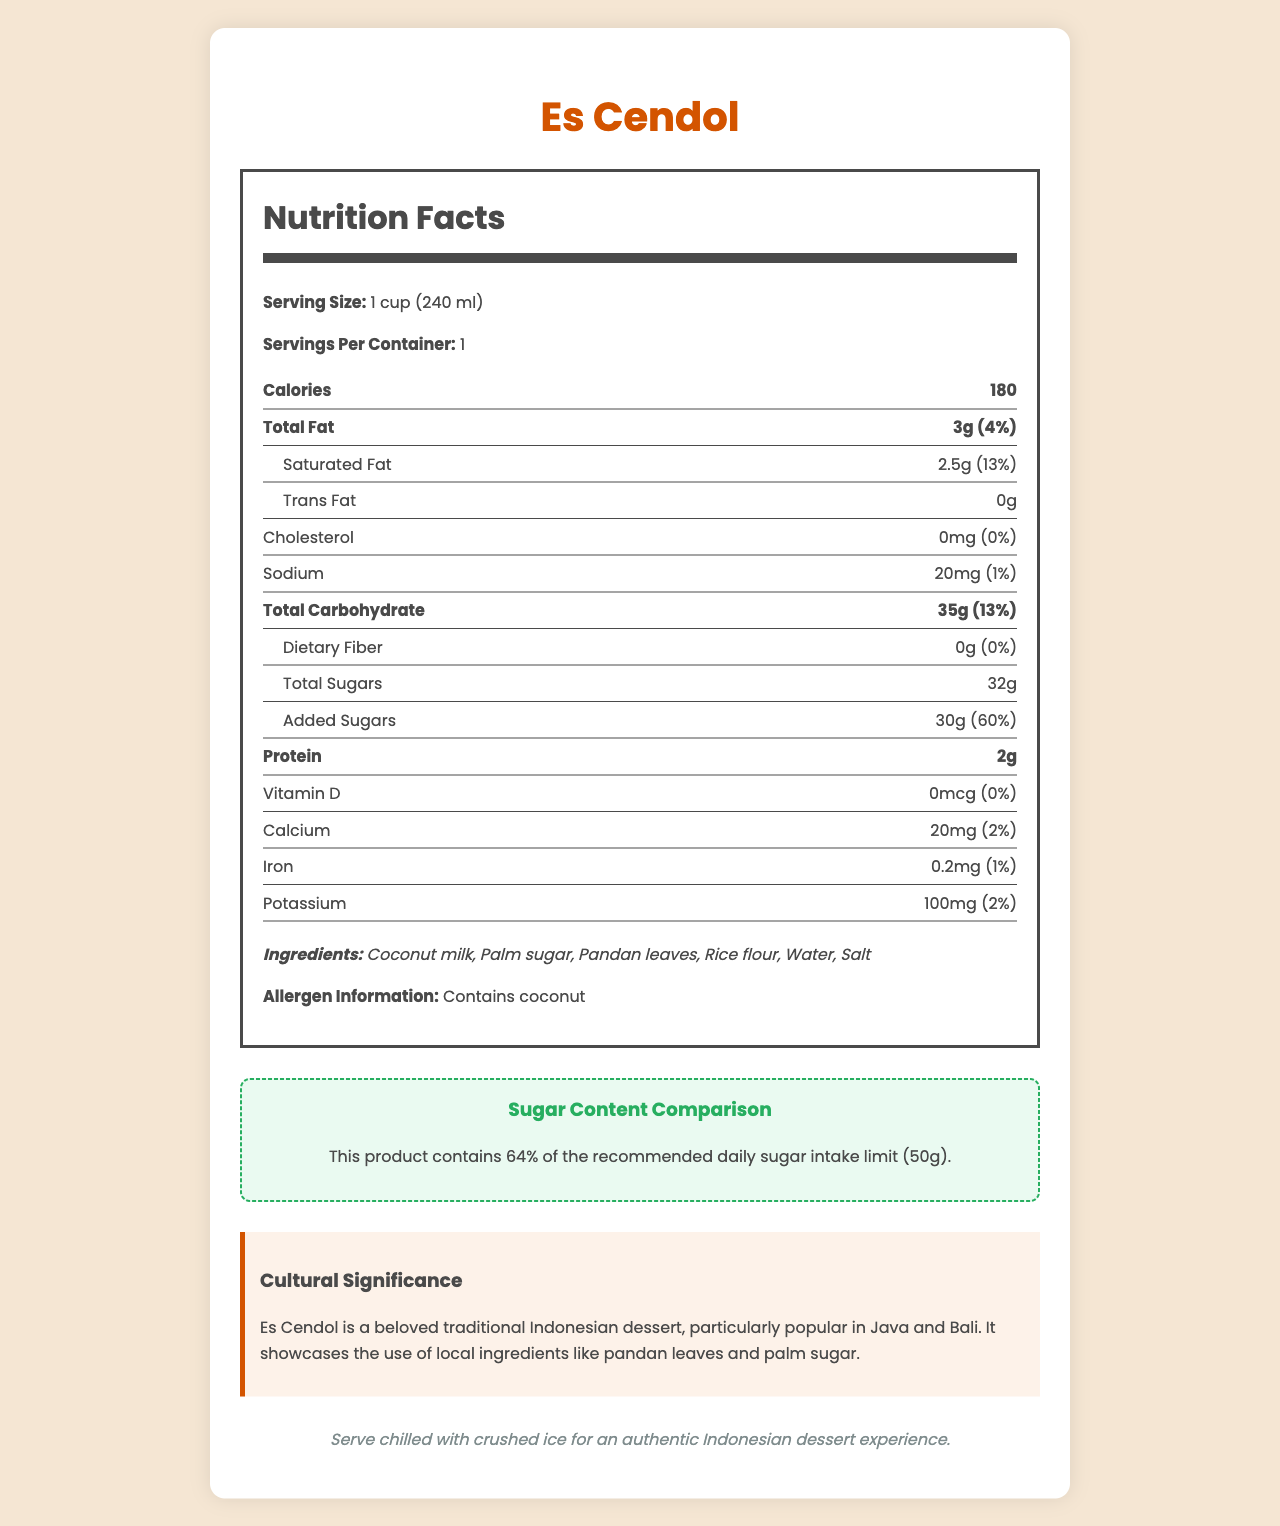what is the serving size of Es Cendol? The document states that the serving size is 1 cup (240 ml).
Answer: 1 cup (240 ml) how many grams of sugar are in a serving of Es Cendol? The document lists the total sugars as 32 grams.
Answer: 32g what percentage of the daily recommended sugar intake does a serving of Es Cendol provide? The document mentions that this product contains 64% of the recommended daily sugar intake.
Answer: 64% what is the total calorie content for one serving of Es Cendol? The document lists the calorie content as 180 calories per serving.
Answer: 180 calories what ingredients are used in Es Cendol? The document lists the ingredients as: Coconut milk, Palm sugar, Pandan leaves, Rice flour, Water, and Salt.
Answer: Coconut milk, Palm sugar, Pandan leaves, Rice flour, Water, Salt how much sodium does one serving of Es Cendol contain? The document states that one serving of Es Cendol contains 20mg of sodium.
Answer: 20mg which of the following vitamins or minerals has the highest percentage of daily value in Es Cendol? A. Iron B. Calcium C. Vitamin D The document shows Calcium has a daily value of 2% which is higher than 0% for both Vitamin D and Iron.
Answer: B. Calcium how much added sugar is in Es Cendol? The document states that there are 30 grams of added sugars, which is 60% of the daily value.
Answer: 30g, 60% of daily value does Es Cendol contain any trans fat? The document lists the trans fat content as 0g.
Answer: No is Es Cendol high in dietary fiber? The document mentions that the dietary fiber content is 0g, which is 0% of the daily value.
Answer: No what traditional significance does Es Cendol have in Indonesia? The document explains that Es Cendol is a beloved traditional Indonesian dessert, popular in Java and Bali, and showcases local ingredients like pandan leaves and palm sugar.
Answer: Particularly popular in Java and Bali, showcasing local ingredients like pandan leaves and palm sugar does Es Cendol contain any allergens? The document states that Es Cendol contains coconut.
Answer: Yes, coconut is the sugar content in Es Cendol considered healthy based on the recommended daily intake? The document mentions that Es Cendol contains 64% of the recommended daily sugar intake, which indicates a high sugar content.
Answer: No describe the main idea of the document. The main idea of the document is to give a comprehensive overview of the nutritional profile, cultural significance, and sugar content comparison for Es Cendol.
Answer: The document provides detailed nutritional information about Es Cendol, a popular Indonesian dessert, including its ingredients, allergen information, cultural significance, and how it compares to the daily recommended sugar intake. how much protein does one serving of Es Cendol provide? The document states that one serving of Es Cendol provides 2 grams of protein.
Answer: 2g what is the daily value percentage of saturated fat in Es Cendol? The document states that the saturated fat content is 2.5g, which is 13% of the daily value.
Answer: 13% If someone is on a low-sodium diet, is Es Cendol a good choice? The document does not provide enough information about other nutritional elements that are important for a low-sodium diet.
Answer: Cannot be determined 